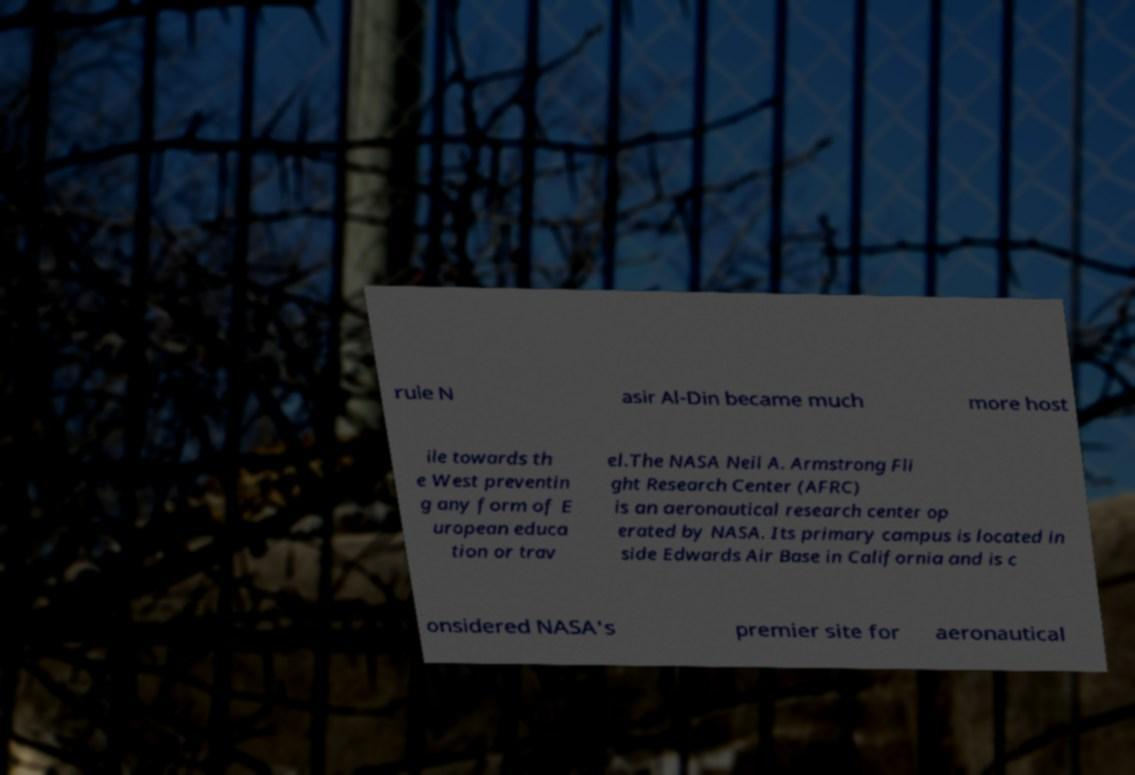Please identify and transcribe the text found in this image. rule N asir Al-Din became much more host ile towards th e West preventin g any form of E uropean educa tion or trav el.The NASA Neil A. Armstrong Fli ght Research Center (AFRC) is an aeronautical research center op erated by NASA. Its primary campus is located in side Edwards Air Base in California and is c onsidered NASA's premier site for aeronautical 